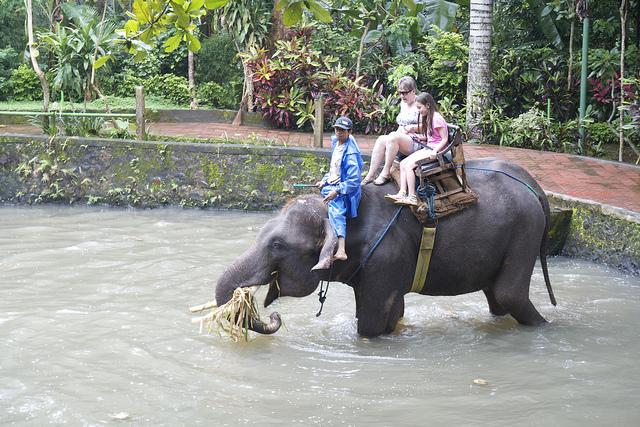How many people are seated on top of the elephant eating in the pool?

Choices:
A) three
B) two
C) six
D) four three 